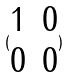Convert formula to latex. <formula><loc_0><loc_0><loc_500><loc_500>( \begin{matrix} 1 & 0 \\ 0 & 0 \end{matrix} )</formula> 